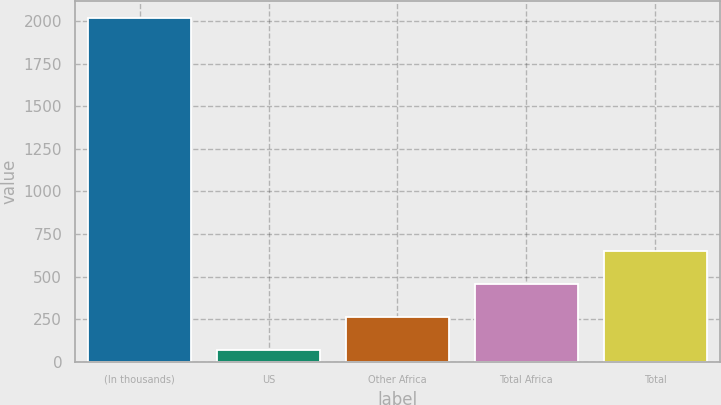<chart> <loc_0><loc_0><loc_500><loc_500><bar_chart><fcel>(In thousands)<fcel>US<fcel>Other Africa<fcel>Total Africa<fcel>Total<nl><fcel>2016<fcel>68<fcel>262.8<fcel>457.6<fcel>652.4<nl></chart> 